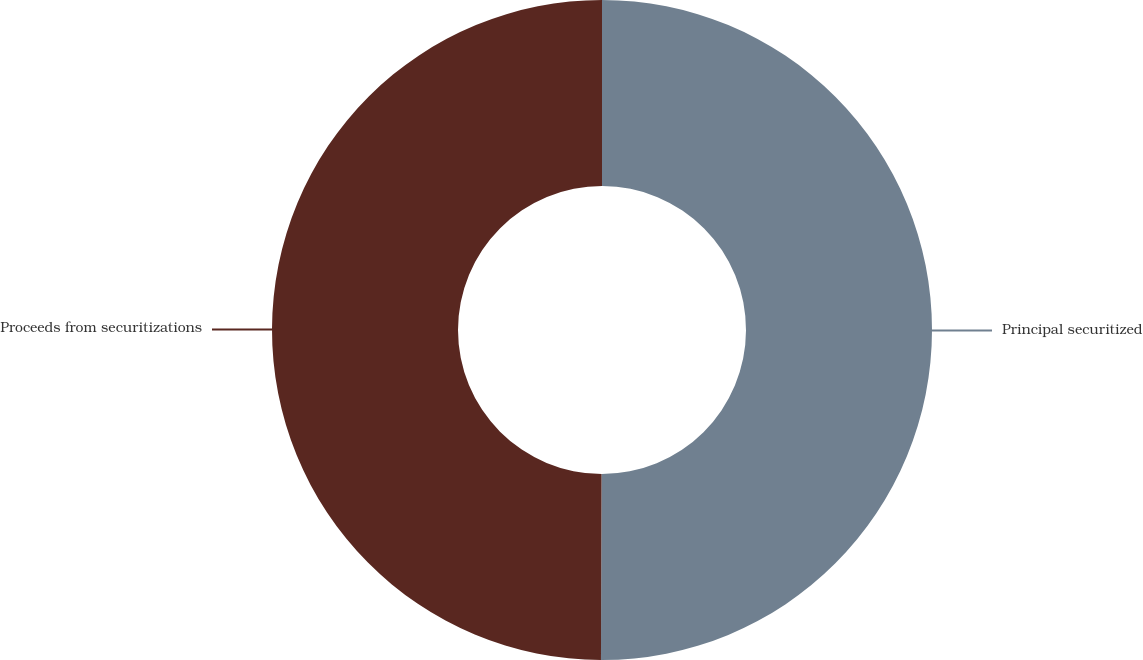<chart> <loc_0><loc_0><loc_500><loc_500><pie_chart><fcel>Principal securitized<fcel>Proceeds from securitizations<nl><fcel>50.05%<fcel>49.95%<nl></chart> 